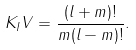<formula> <loc_0><loc_0><loc_500><loc_500>K _ { I } V = \frac { ( l + m ) ! } { m ( l - m ) ! } .</formula> 